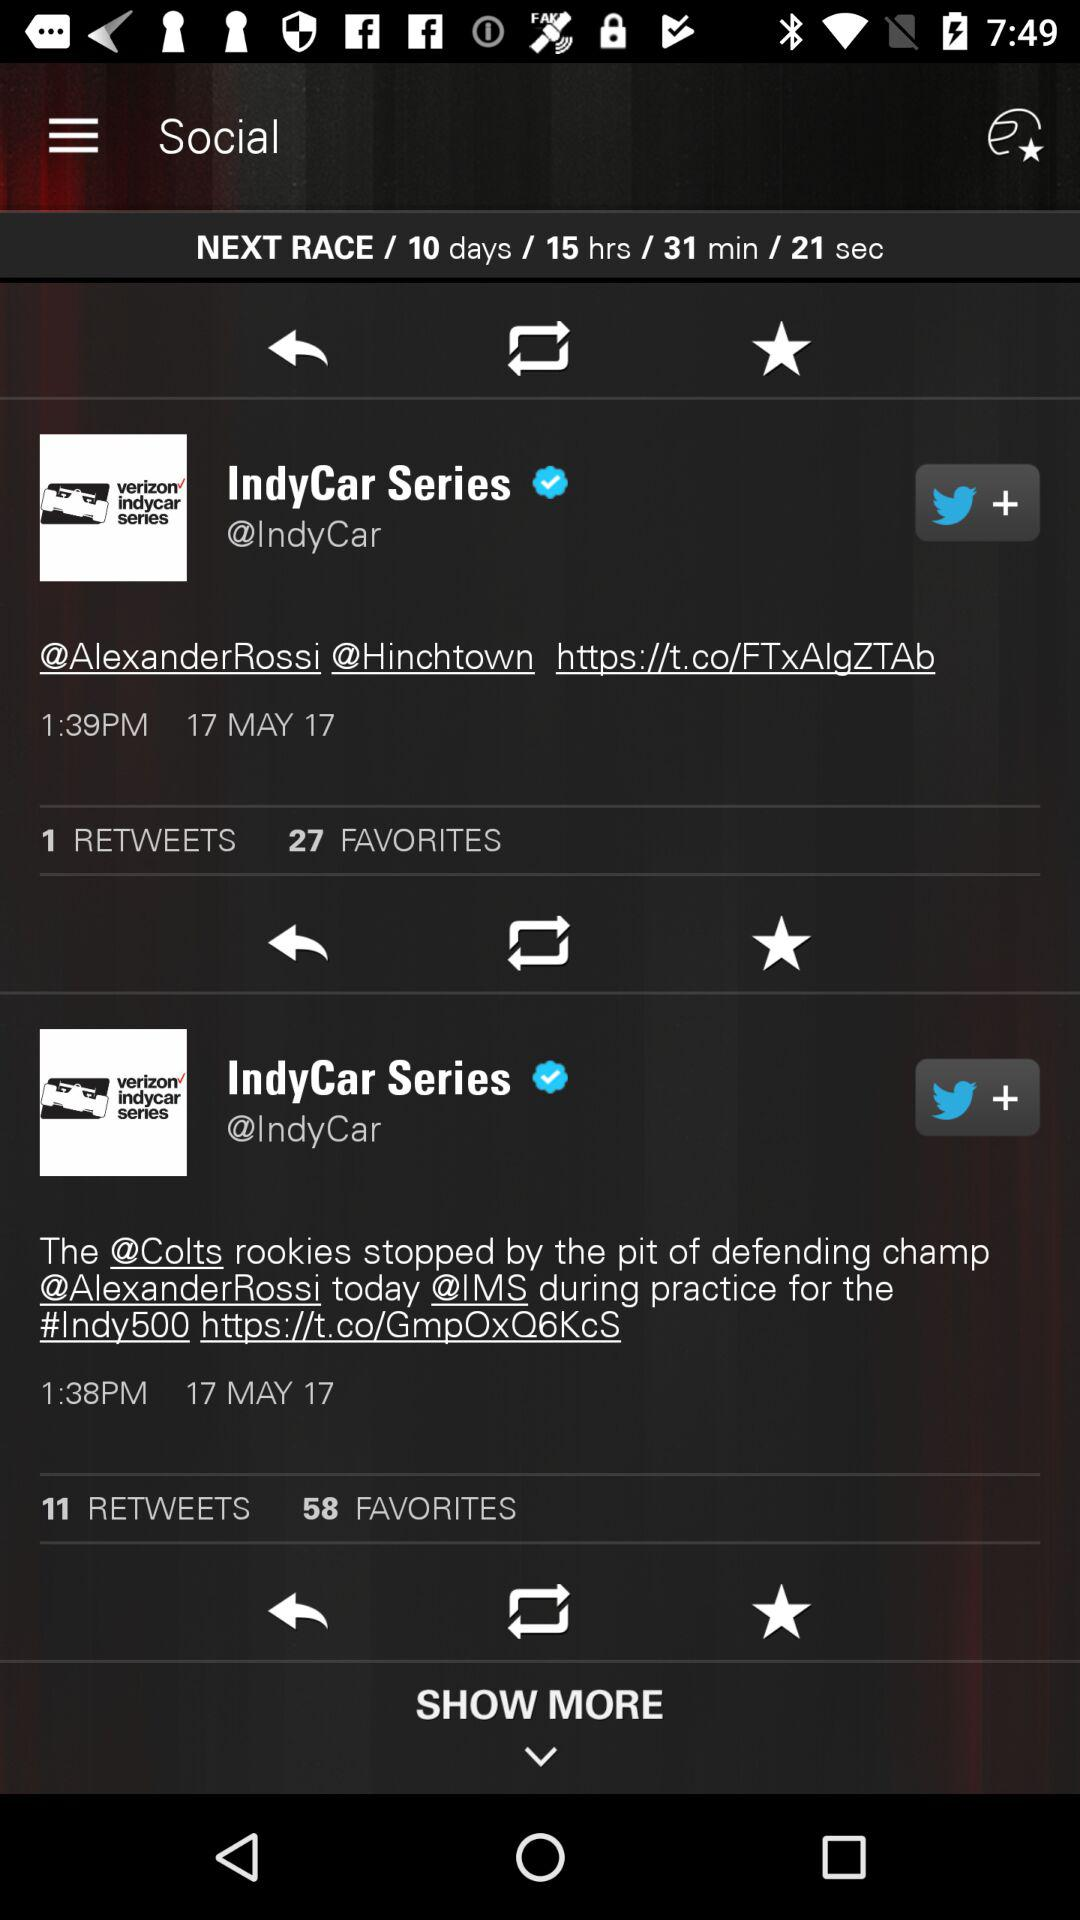How many favorites are there for the tweet done at 1:38 PM? There are 58 favorites. 